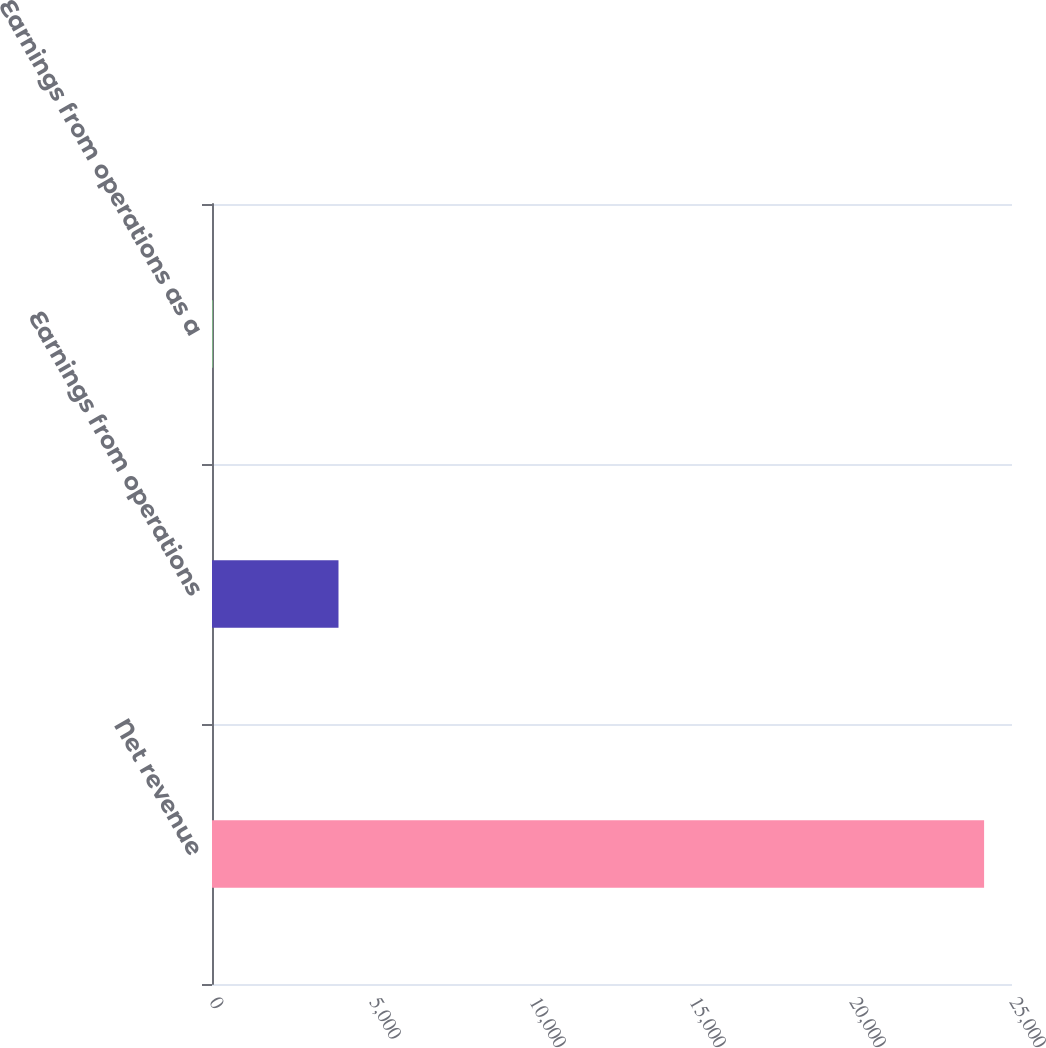Convert chart. <chart><loc_0><loc_0><loc_500><loc_500><bar_chart><fcel>Net revenue<fcel>Earnings from operations<fcel>Earnings from operations as a<nl><fcel>24128<fcel>3953<fcel>16.4<nl></chart> 